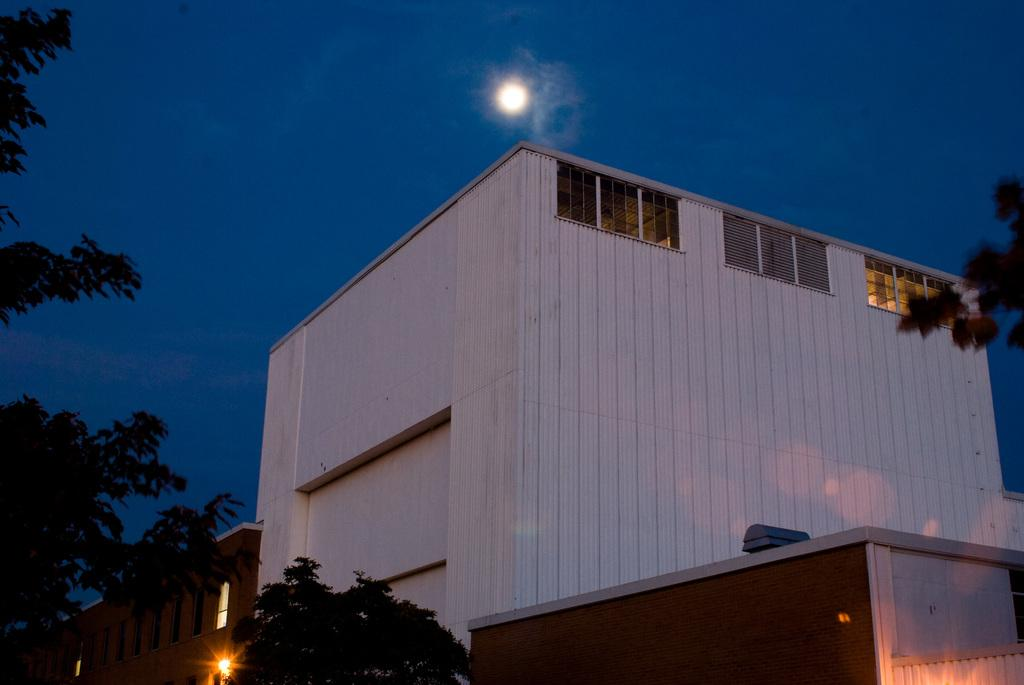What type of structures are present in the image? There are buildings with windows in the image. What other natural elements can be seen in the image? There are trees in the image. Are there any artificial light sources visible in the image? Yes, there are lights visible in the image. What is visible in the sky in the image? The sky is visible in the image, and there is a moon in the sky. What type of screw can be seen holding the coach together in the image? There is no coach or screw present in the image; it features buildings, trees, lights, and a moon in the sky. What type of sun is visible in the image? There is no sun visible in the image; it features a moon in the sky. 